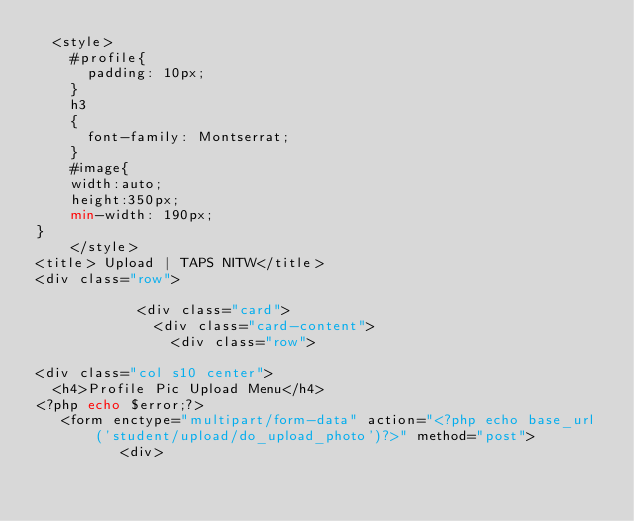Convert code to text. <code><loc_0><loc_0><loc_500><loc_500><_PHP_>  <style>
    #profile{
      padding: 10px;
    }
    h3
    {
      font-family: Montserrat;
    }
    #image{
    width:auto;
    height:350px;
    min-width: 190px;
}
    </style>
<title> Upload | TAPS NITW</title>
<div class="row">

            <div class="card">
              <div class="card-content">
                <div class="row">

<div class="col s10 center">
	<h4>Profile Pic Upload Menu</h4>
<?php echo $error;?>
   <form enctype="multipart/form-data" action="<?php echo base_url('student/upload/do_upload_photo')?>" method="post">
          <div></code> 